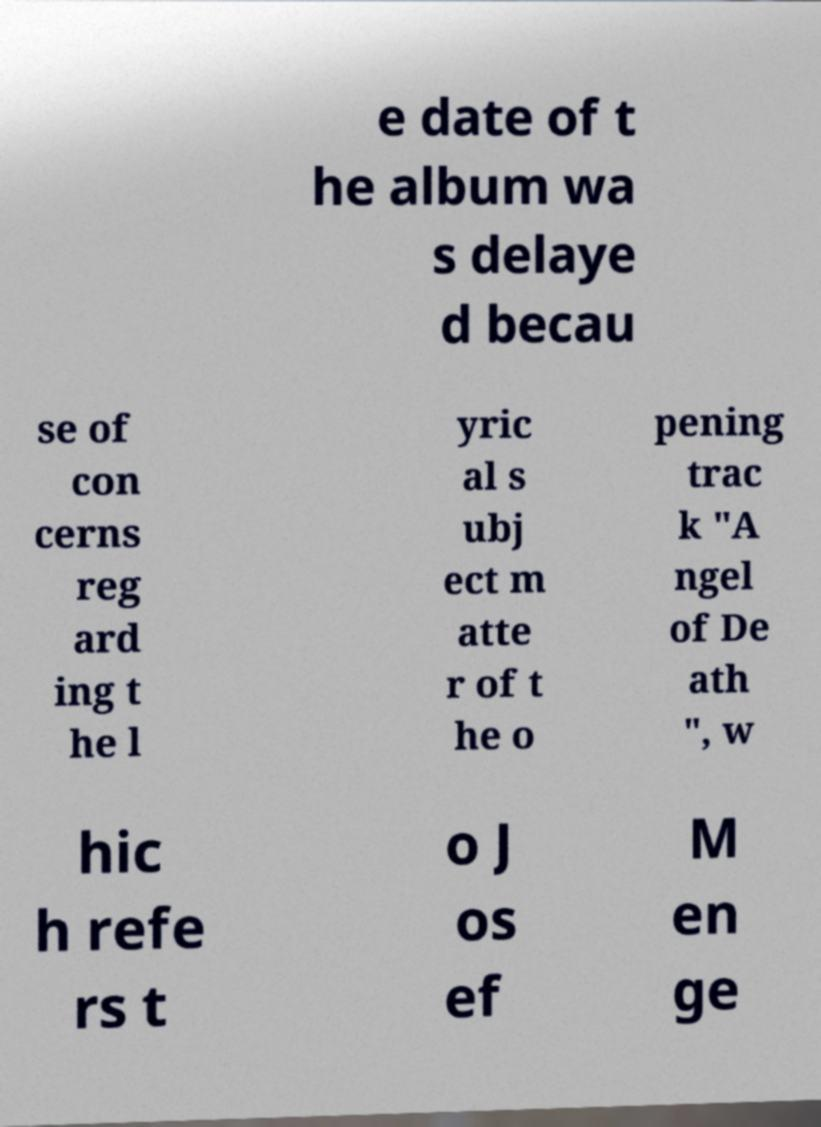Could you assist in decoding the text presented in this image and type it out clearly? e date of t he album wa s delaye d becau se of con cerns reg ard ing t he l yric al s ubj ect m atte r of t he o pening trac k "A ngel of De ath ", w hic h refe rs t o J os ef M en ge 